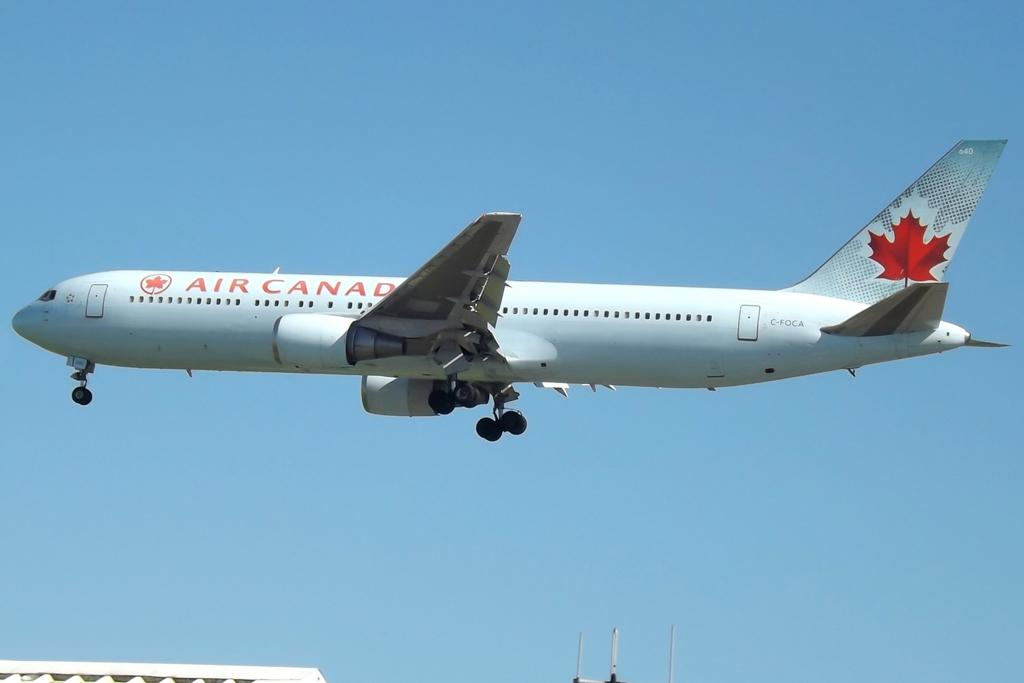<image>
Create a compact narrative representing the image presented. a white and red air canada plane in a clear blue sky 